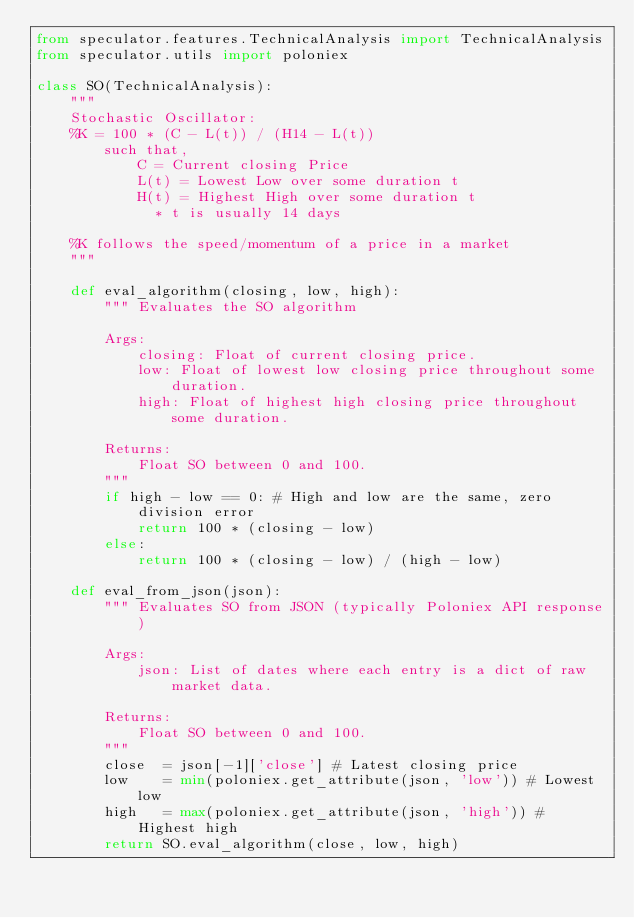Convert code to text. <code><loc_0><loc_0><loc_500><loc_500><_Python_>from speculator.features.TechnicalAnalysis import TechnicalAnalysis
from speculator.utils import poloniex

class SO(TechnicalAnalysis):
    """
    Stochastic Oscillator:
    %K = 100 * (C - L(t)) / (H14 - L(t))
        such that,
            C = Current closing Price
            L(t) = Lowest Low over some duration t
            H(t) = Highest High over some duration t
              * t is usually 14 days

    %K follows the speed/momentum of a price in a market
    """

    def eval_algorithm(closing, low, high):
        """ Evaluates the SO algorithm

        Args:
            closing: Float of current closing price.
            low: Float of lowest low closing price throughout some duration.
            high: Float of highest high closing price throughout some duration.

        Returns:
            Float SO between 0 and 100.
        """
        if high - low == 0: # High and low are the same, zero division error
            return 100 * (closing - low)
        else:
            return 100 * (closing - low) / (high - low)

    def eval_from_json(json):
        """ Evaluates SO from JSON (typically Poloniex API response)

        Args:
            json: List of dates where each entry is a dict of raw market data.

        Returns:
            Float SO between 0 and 100.
        """
        close  = json[-1]['close'] # Latest closing price
        low    = min(poloniex.get_attribute(json, 'low')) # Lowest low
        high   = max(poloniex.get_attribute(json, 'high')) # Highest high
        return SO.eval_algorithm(close, low, high)
</code> 